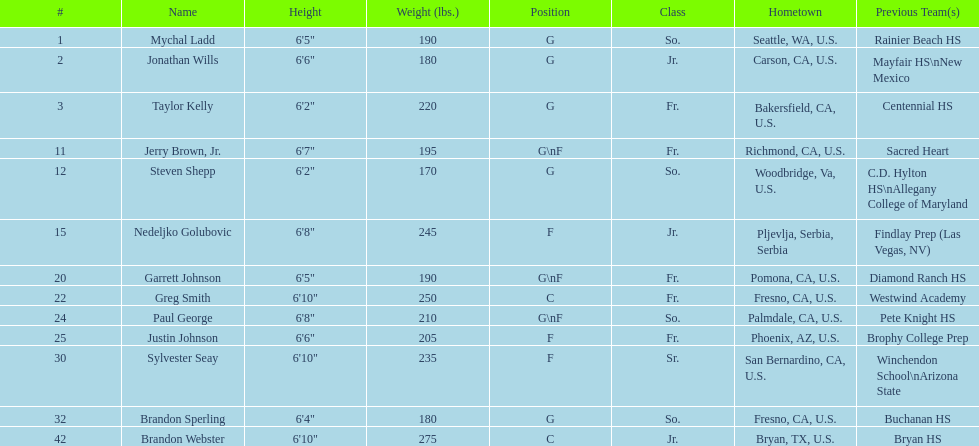Who weighs the most on the team? Brandon Webster. 